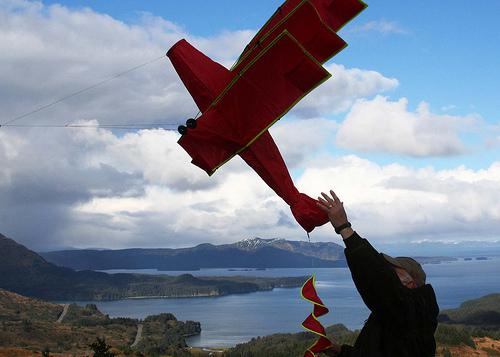Question: how is the weather?
Choices:
A. Stormy.
B. Overcast.
C. Clear.
D. Snowy.
Answer with the letter. Answer: C Question: where was this picture taken?
Choices:
A. The seaside.
B. The mountain.
C. The beach.
D. At home.
Answer with the letter. Answer: A Question: what is the man doing?
Choices:
A. Flying a kite.
B. Reading.
C. Talking.
D. Dancing.
Answer with the letter. Answer: A 